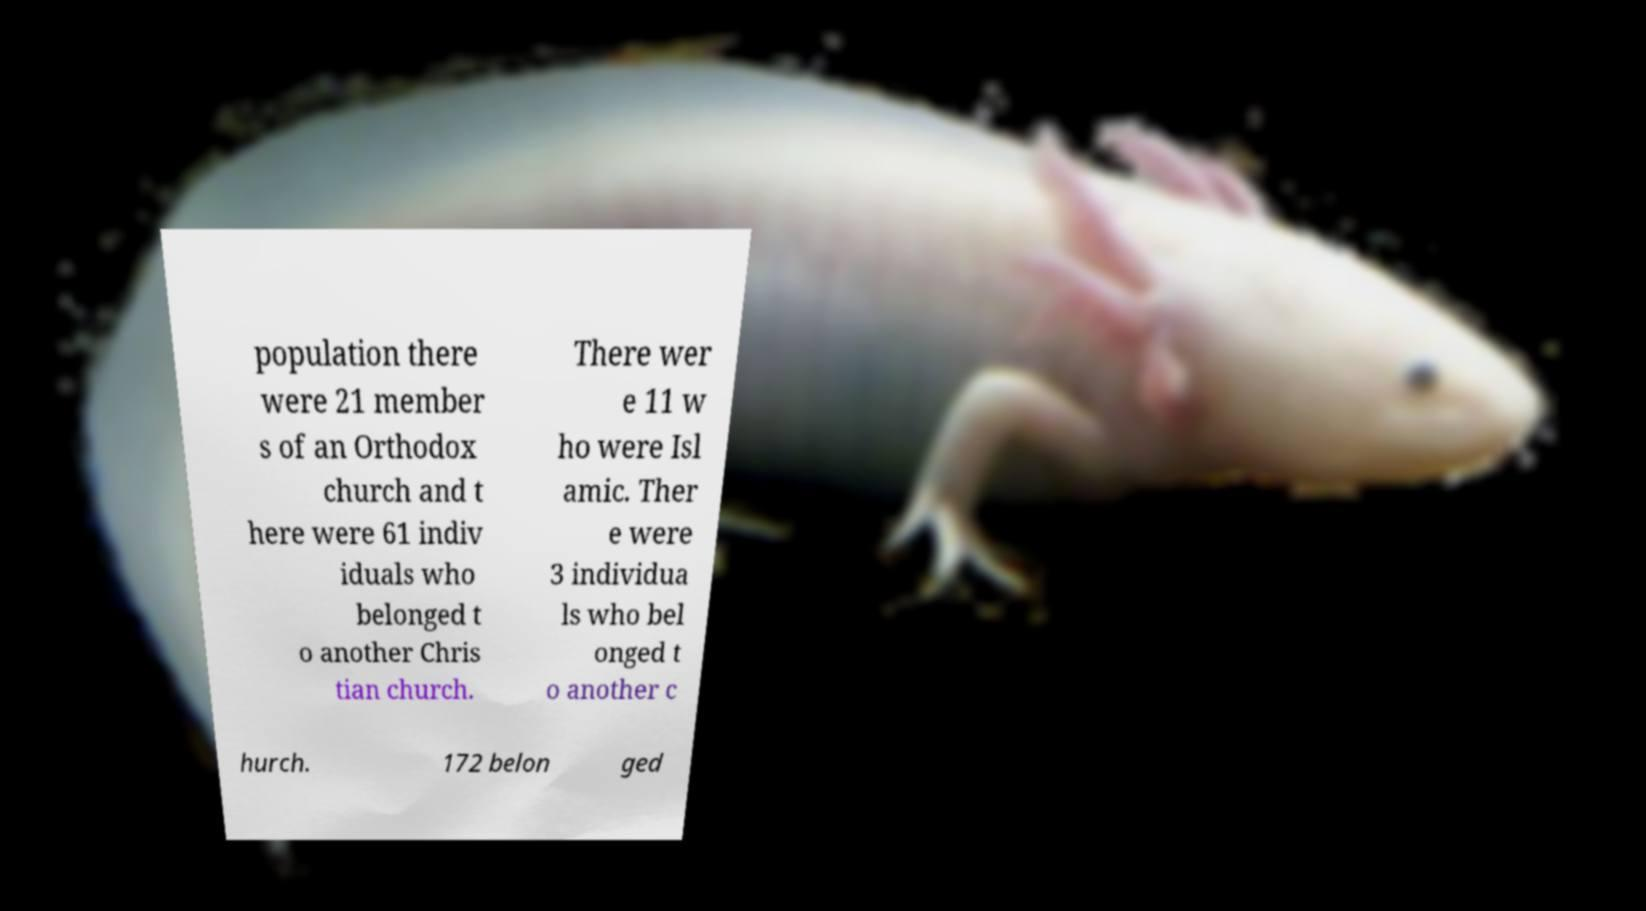Please read and relay the text visible in this image. What does it say? population there were 21 member s of an Orthodox church and t here were 61 indiv iduals who belonged t o another Chris tian church. There wer e 11 w ho were Isl amic. Ther e were 3 individua ls who bel onged t o another c hurch. 172 belon ged 